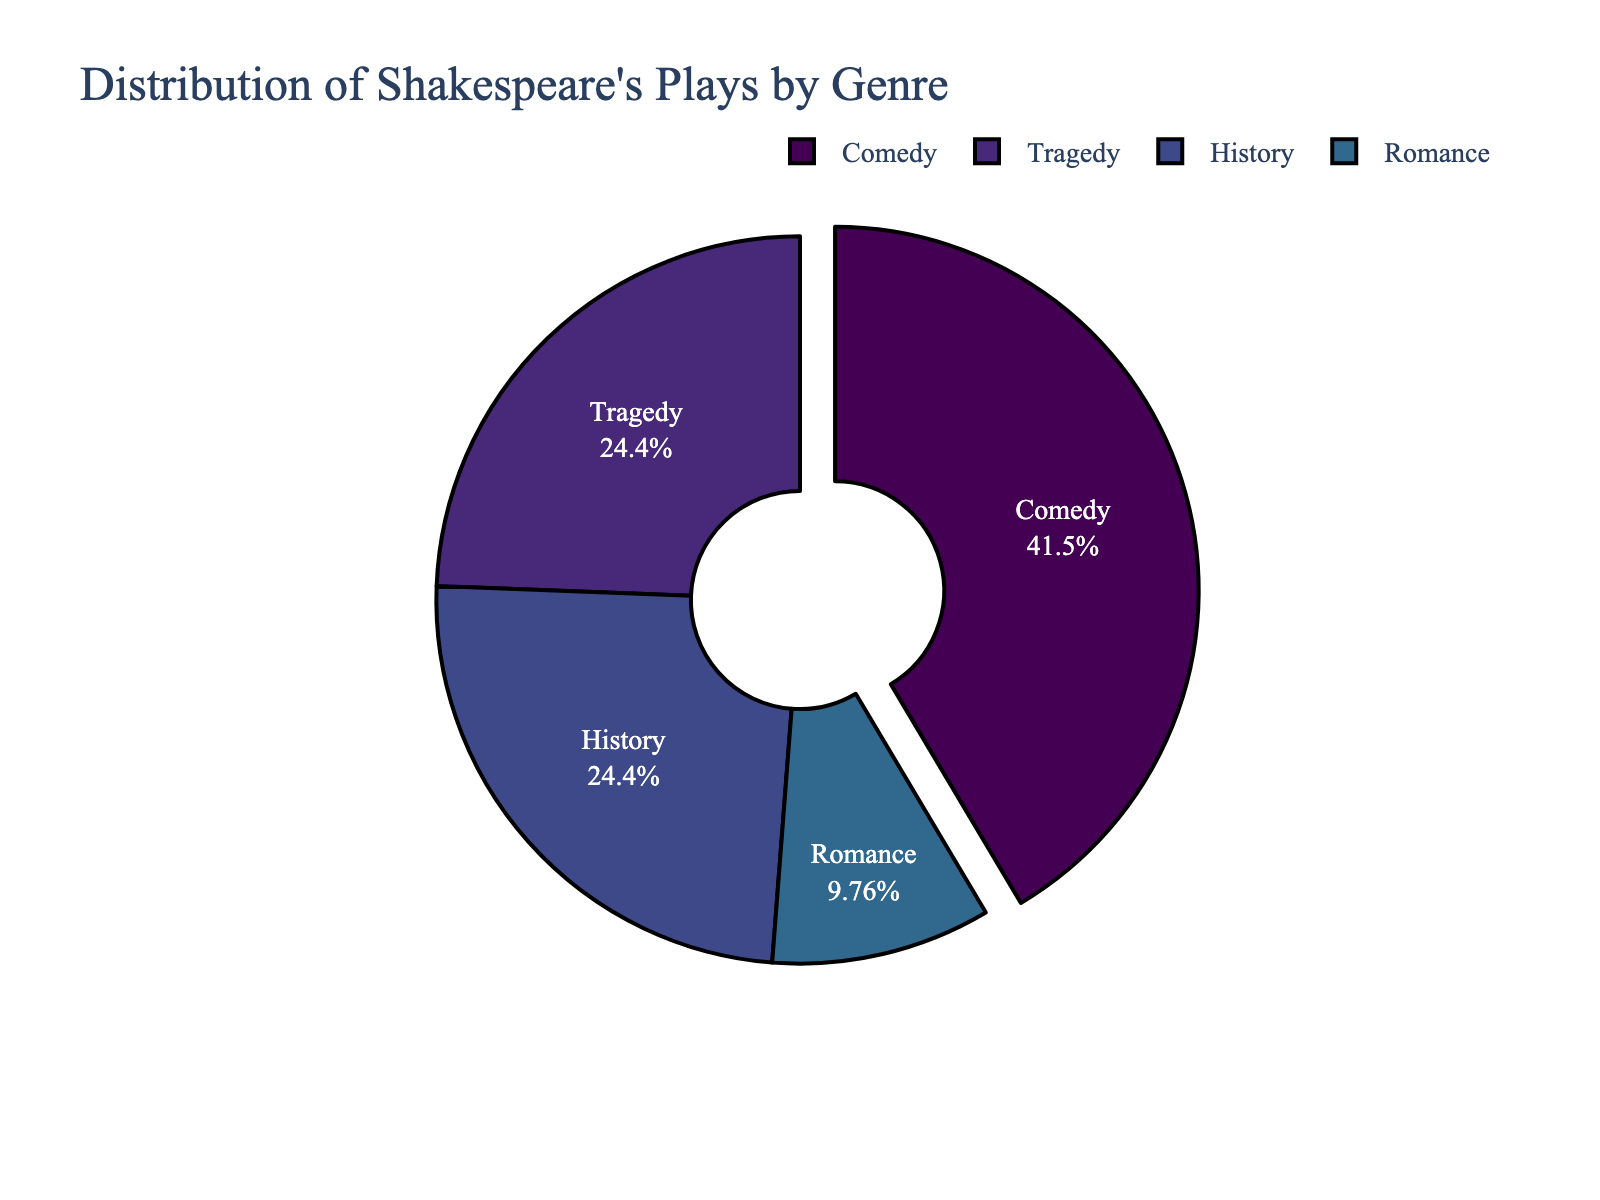What percentage of Shakespeare's plays are Comedies? Look at the pie chart and locate the section labeled "Comedy". The text inside this section will show the percentage of plays that are comedies.
Answer: 45% Which genre has the smallest number of plays? Identify the segment of the pie chart with the smallest area. This segment represents the genre with the fewest plays.
Answer: Romance Are there more Tragedies than Romances? Compare the size of the sections labeled "Tragedy" and "Romance" in the pie chart. Determine which section is larger.
Answer: Yes How many more Comedies are there compared to Histories and Romances combined? Locate the number of plays for Comedy (17), History (10), and Romance (4). Calculate the combined number for History and Romance (10 + 4 = 14). Subtract this from the number for Comedy (17 - 14).
Answer: 3 If you combined all the non-Comedy genres, how many plays would that be? Add the number of plays in Tragedy (10), History (10), and Romance (4). Sum these up: 10 + 10 + 4 = 24.
Answer: 24 What is the ratio of Comedies to Tragedies? Find the number of plays labeled as Comedies (17) and the number labeled as Tragedies (10). Use these numbers to form a ratio: 17:10.
Answer: 17:10 Which two genres have an equal number of plays? Compare the numbers in each genre's section of the pie chart. Identify if any two numbers are equal.
Answer: Tragedy and History What fraction of Shakespeare's plays are Romances? Identify the number of Romance plays (4). Sum the total number of plays (17 + 10 + 10 + 4 = 41). Divide the number of Romance plays by the total number of plays (4/41). Simplify if possible.
Answer: 4/41 By what percentage is the number of Comedies greater than the number of Tragedies? Calculate the difference between the number of Comedies and Tragedies (17 - 10 = 7). Divide this difference by the number of Tragedies (7/10). Multiply by 100 to convert it to a percentage (7/10*100 = 70%).
Answer: 70% 